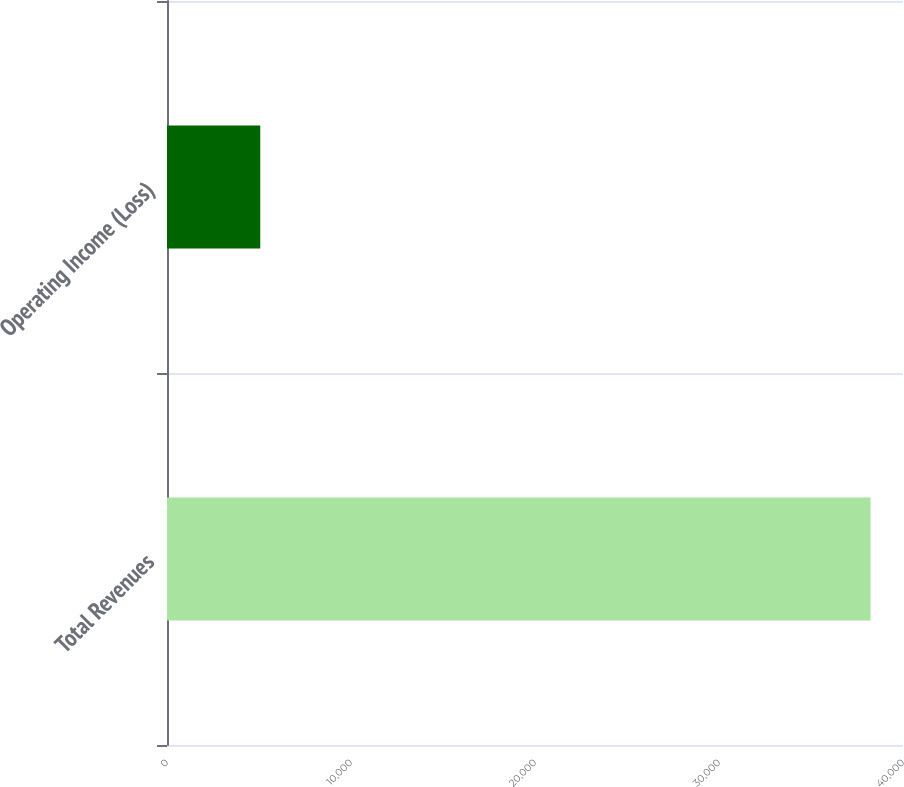Convert chart to OTSL. <chart><loc_0><loc_0><loc_500><loc_500><bar_chart><fcel>Total Revenues<fcel>Operating Income (Loss)<nl><fcel>38236<fcel>5069<nl></chart> 